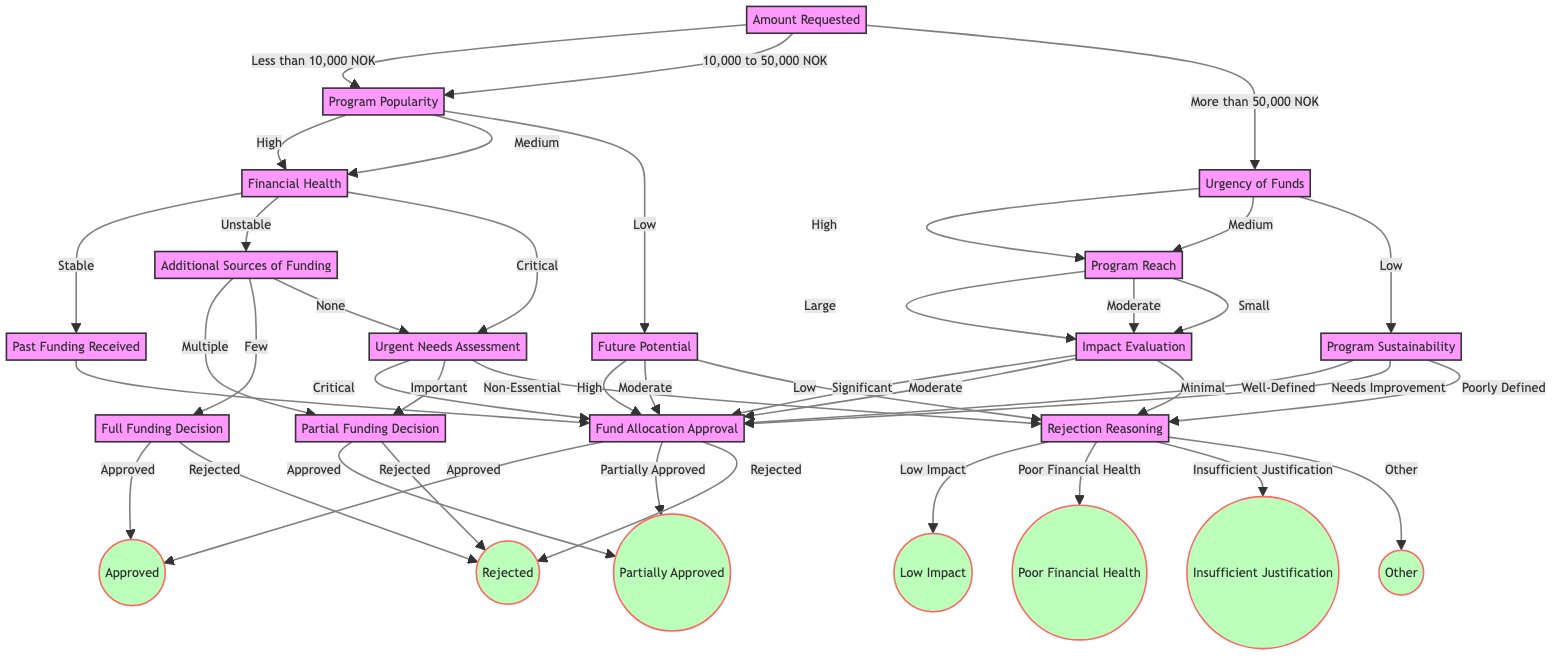What happens if the amount requested is more than 50,000 NOK? The flow progresses to the "Urgency of Funds" node, indicating that after the amount exceeds this threshold, the urgency becomes a critical factor in the decision-making process.
Answer: Urgency of Funds What is the next step if the program's popularity is rated as low? If the program's popularity is low, the following step is to assess the "Future Potential" of the sports program. This involves evaluating potential growth and benefits.
Answer: Future Potential How many outcomes are there from the "Fund Allocation Approval" node? From the "Fund Allocation Approval" node, there are three possible outcomes: Approved, Partially Approved, and Rejected.
Answer: Three What are the implications if the financial health of a program is categorized as unstable? If categorized as unstable, the next assessment focuses on "Additional Sources of Funding," which questions the available external funding opportunities for the program.
Answer: Additional Sources of Funding What should be assessed if the program reach is classified as small? Regardless of the classification, the flow always leads to "Impact Evaluation," where the overall impact of the program on the community will be evaluated.
Answer: Impact Evaluation What is the decision pathway if past funding received is significant? The pathway leads straight to "Fund Allocation Approval," meaning that a significant past received amount leads directly to the final funding decision process without further considerations.
Answer: Fund Allocation Approval If the urgency of funds is assessed as low, what will be the next evaluation? The evaluation will focus on the "Program Sustainability," where the long-term sustainability plan of the program will be scrutinized for its potential to continue successfully.
Answer: Program Sustainability What happens if there are no additional sources of funding? If there are no additional sources of funding, the flow directs to "Urgent Needs Assessment," where critical needs for the program will be determined based on the situation's urgency.
Answer: Urgent Needs Assessment What result is reached when the impact evaluation indicates minimal impact? If the impact evaluation shows minimal impact, the diagram indicates that the funding request would be "Rejected."
Answer: Rejected 